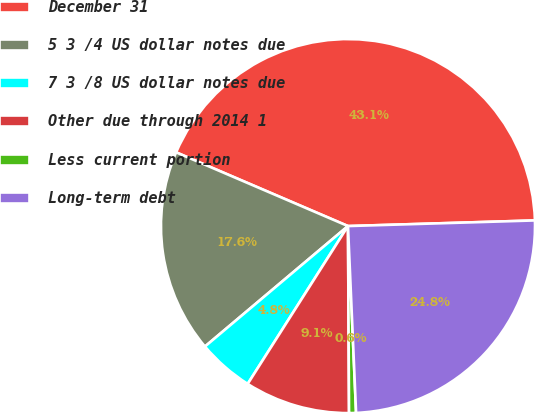<chart> <loc_0><loc_0><loc_500><loc_500><pie_chart><fcel>December 31<fcel>5 3 /4 US dollar notes due<fcel>7 3 /8 US dollar notes due<fcel>Other due through 2014 1<fcel>Less current portion<fcel>Long-term debt<nl><fcel>43.07%<fcel>17.59%<fcel>4.85%<fcel>9.1%<fcel>0.6%<fcel>24.79%<nl></chart> 